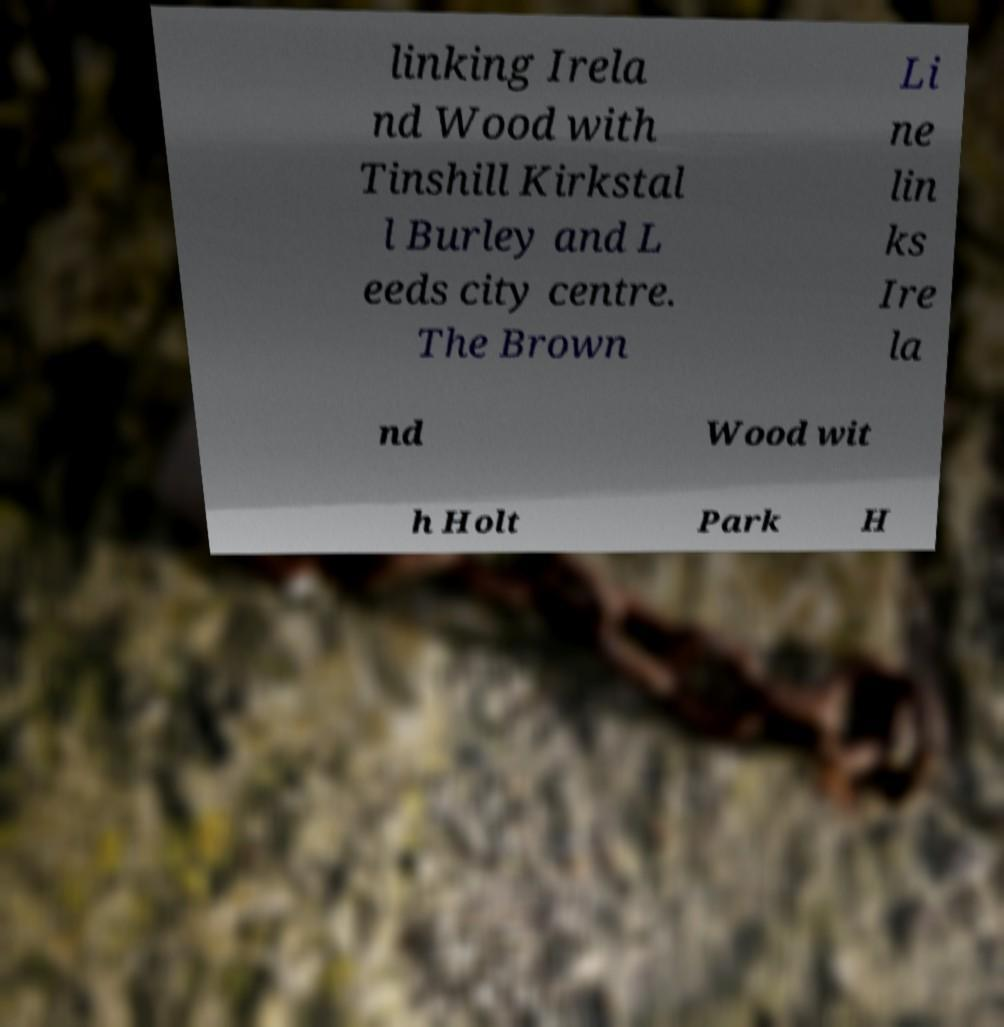For documentation purposes, I need the text within this image transcribed. Could you provide that? linking Irela nd Wood with Tinshill Kirkstal l Burley and L eeds city centre. The Brown Li ne lin ks Ire la nd Wood wit h Holt Park H 